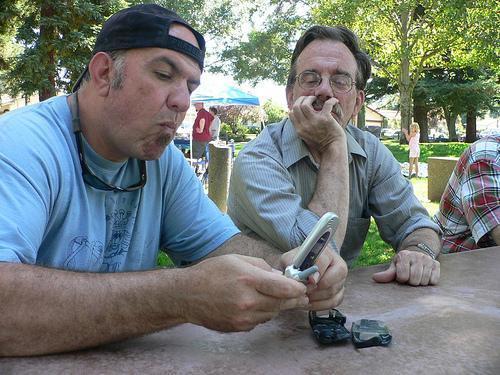How many people can be seen?
Give a very brief answer. 3. 